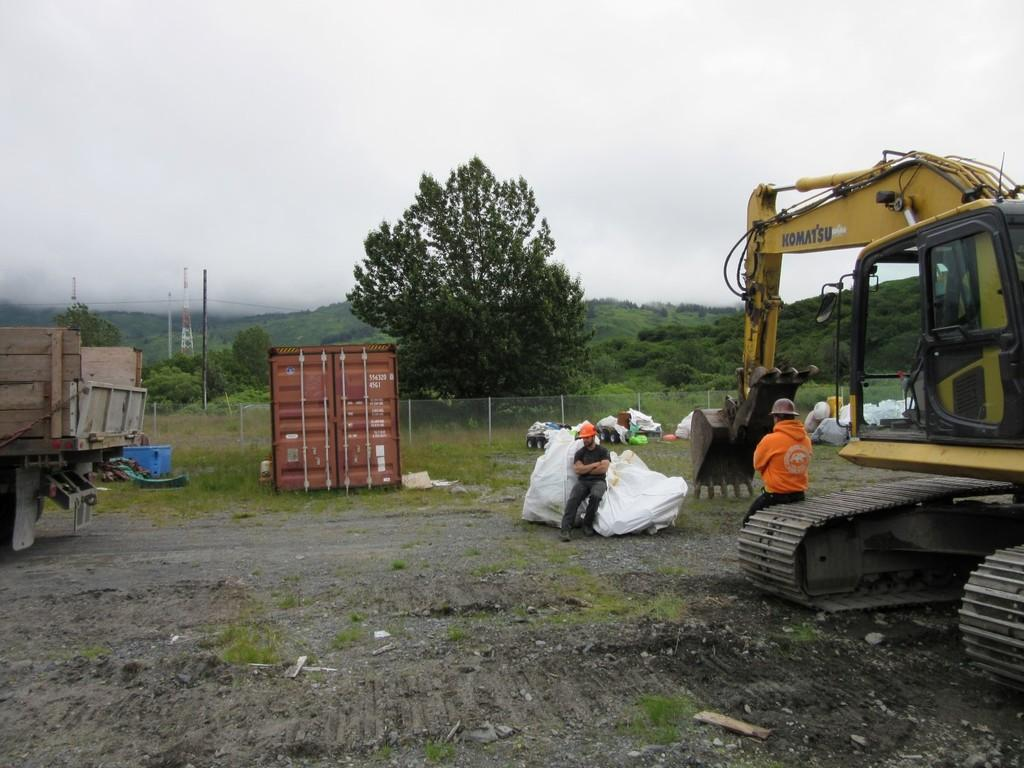<image>
Summarize the visual content of the image. people sit near a KOMATSU construction vehicle in a field 